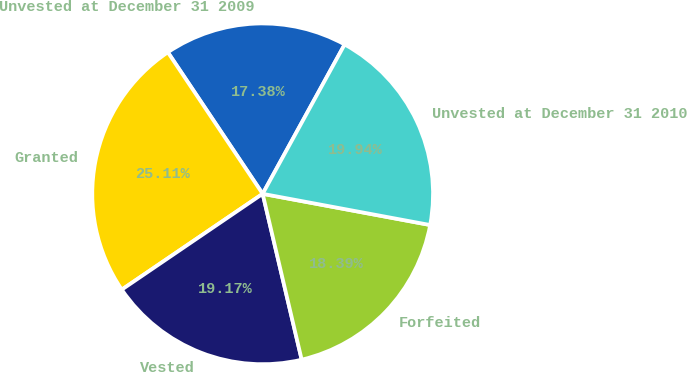Convert chart. <chart><loc_0><loc_0><loc_500><loc_500><pie_chart><fcel>Unvested at December 31 2009<fcel>Granted<fcel>Vested<fcel>Forfeited<fcel>Unvested at December 31 2010<nl><fcel>17.38%<fcel>25.11%<fcel>19.17%<fcel>18.39%<fcel>19.94%<nl></chart> 